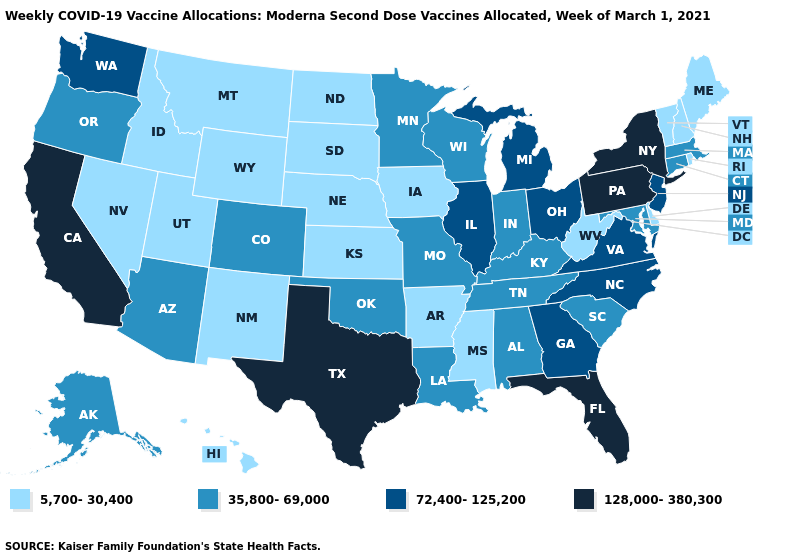Name the states that have a value in the range 35,800-69,000?
Give a very brief answer. Alabama, Alaska, Arizona, Colorado, Connecticut, Indiana, Kentucky, Louisiana, Maryland, Massachusetts, Minnesota, Missouri, Oklahoma, Oregon, South Carolina, Tennessee, Wisconsin. Does Rhode Island have the highest value in the Northeast?
Keep it brief. No. Does Michigan have the highest value in the MidWest?
Be succinct. Yes. Among the states that border California , which have the highest value?
Concise answer only. Arizona, Oregon. What is the value of Alabama?
Keep it brief. 35,800-69,000. What is the value of Alaska?
Keep it brief. 35,800-69,000. Among the states that border Pennsylvania , does New Jersey have the highest value?
Quick response, please. No. Name the states that have a value in the range 72,400-125,200?
Answer briefly. Georgia, Illinois, Michigan, New Jersey, North Carolina, Ohio, Virginia, Washington. What is the lowest value in states that border Michigan?
Be succinct. 35,800-69,000. What is the value of Idaho?
Be succinct. 5,700-30,400. Which states have the lowest value in the West?
Be succinct. Hawaii, Idaho, Montana, Nevada, New Mexico, Utah, Wyoming. Does the first symbol in the legend represent the smallest category?
Keep it brief. Yes. What is the value of California?
Be succinct. 128,000-380,300. Does New Jersey have the highest value in the Northeast?
Keep it brief. No. What is the value of Kentucky?
Be succinct. 35,800-69,000. 